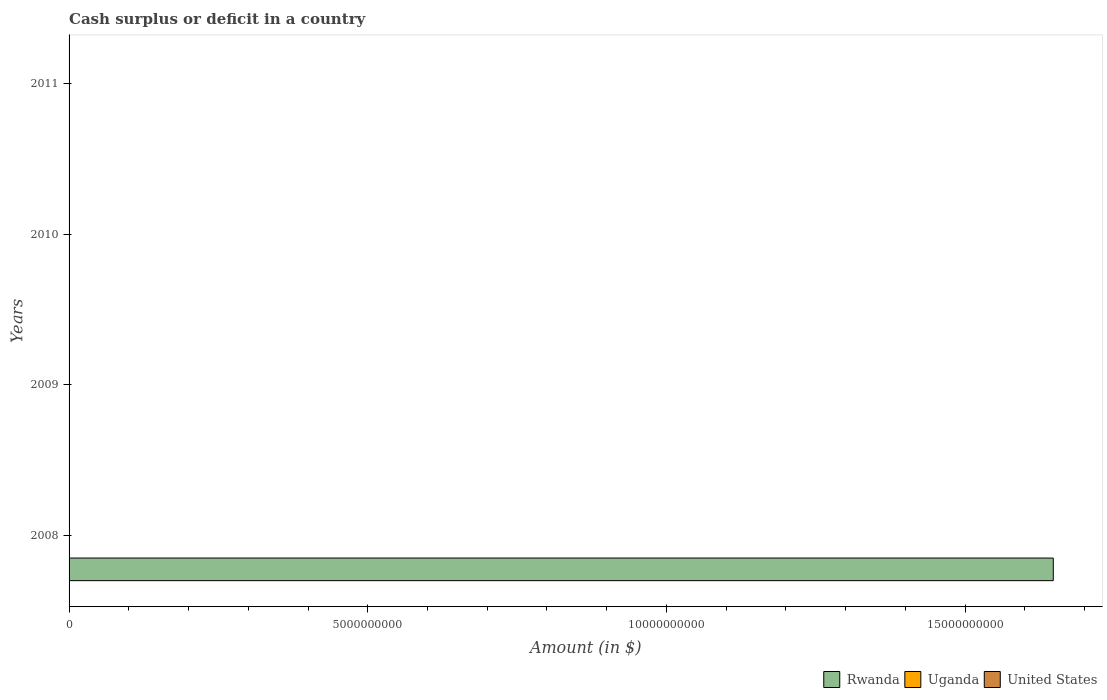Are the number of bars per tick equal to the number of legend labels?
Give a very brief answer. No. Are the number of bars on each tick of the Y-axis equal?
Offer a terse response. No. How many bars are there on the 4th tick from the bottom?
Your answer should be compact. 0. Across all years, what is the maximum amount of cash surplus or deficit in Rwanda?
Ensure brevity in your answer.  1.65e+1. Across all years, what is the minimum amount of cash surplus or deficit in Uganda?
Your answer should be compact. 0. What is the total amount of cash surplus or deficit in Rwanda in the graph?
Keep it short and to the point. 1.65e+1. What is the average amount of cash surplus or deficit in Rwanda per year?
Provide a succinct answer. 4.12e+09. What is the difference between the highest and the lowest amount of cash surplus or deficit in Rwanda?
Ensure brevity in your answer.  1.65e+1. Is it the case that in every year, the sum of the amount of cash surplus or deficit in United States and amount of cash surplus or deficit in Uganda is greater than the amount of cash surplus or deficit in Rwanda?
Make the answer very short. No. Where does the legend appear in the graph?
Offer a very short reply. Bottom right. How many legend labels are there?
Ensure brevity in your answer.  3. What is the title of the graph?
Make the answer very short. Cash surplus or deficit in a country. What is the label or title of the X-axis?
Offer a very short reply. Amount (in $). What is the label or title of the Y-axis?
Offer a terse response. Years. What is the Amount (in $) of Rwanda in 2008?
Your answer should be compact. 1.65e+1. What is the Amount (in $) of Uganda in 2009?
Ensure brevity in your answer.  0. What is the Amount (in $) of Rwanda in 2010?
Your answer should be very brief. 0. What is the Amount (in $) in United States in 2010?
Your response must be concise. 0. What is the Amount (in $) in Rwanda in 2011?
Your answer should be compact. 0. What is the Amount (in $) in Uganda in 2011?
Your response must be concise. 0. What is the Amount (in $) of United States in 2011?
Provide a short and direct response. 0. Across all years, what is the maximum Amount (in $) in Rwanda?
Keep it short and to the point. 1.65e+1. Across all years, what is the minimum Amount (in $) of Rwanda?
Offer a terse response. 0. What is the total Amount (in $) in Rwanda in the graph?
Provide a succinct answer. 1.65e+1. What is the total Amount (in $) of Uganda in the graph?
Offer a terse response. 0. What is the average Amount (in $) of Rwanda per year?
Give a very brief answer. 4.12e+09. What is the average Amount (in $) in United States per year?
Offer a terse response. 0. What is the difference between the highest and the lowest Amount (in $) in Rwanda?
Make the answer very short. 1.65e+1. 